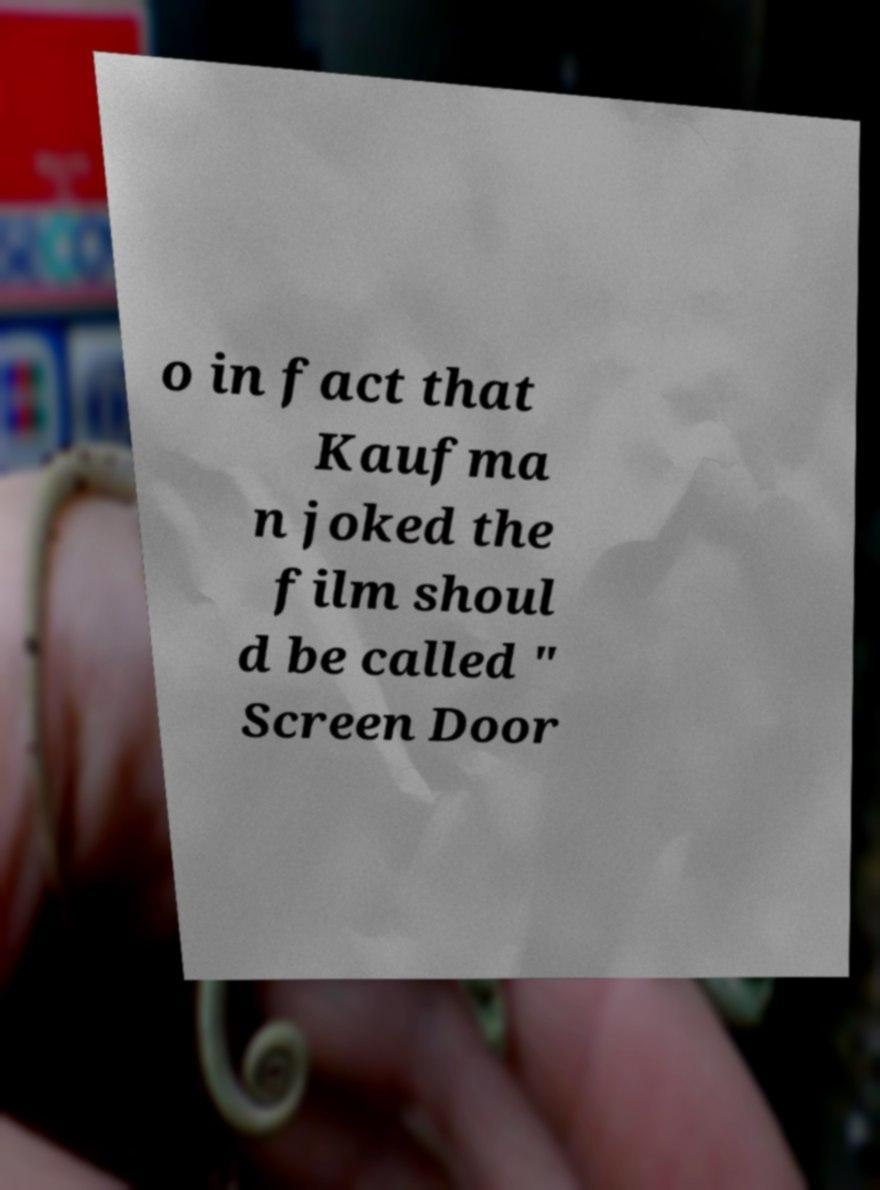Can you accurately transcribe the text from the provided image for me? o in fact that Kaufma n joked the film shoul d be called " Screen Door 